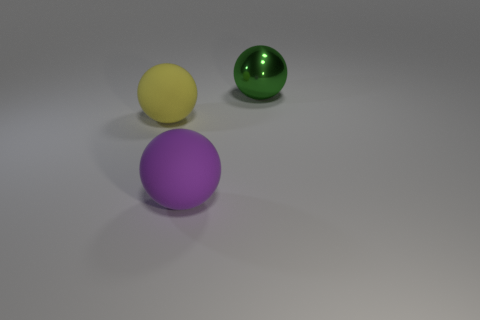Can you describe the colors of the objects? Certainly! There are three spherical objects in different colors: one is yellow, another is green with a shiny surface, and the third one is purple. 